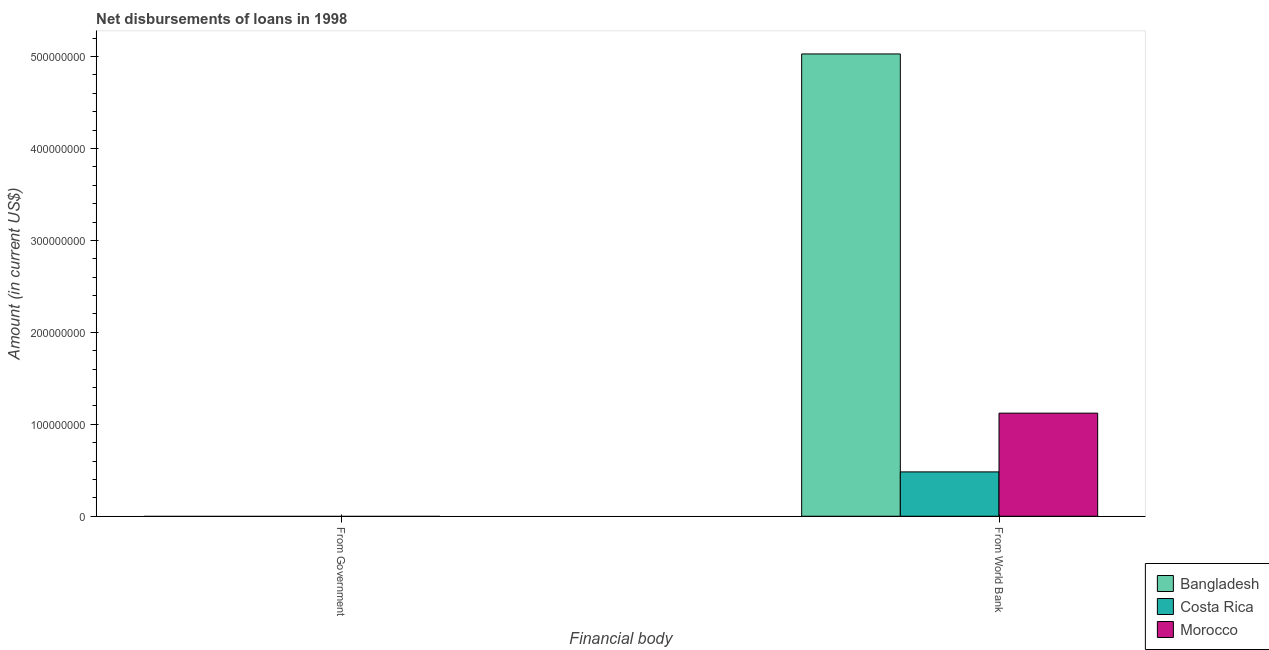Are the number of bars per tick equal to the number of legend labels?
Ensure brevity in your answer.  No. Are the number of bars on each tick of the X-axis equal?
Ensure brevity in your answer.  No. What is the label of the 2nd group of bars from the left?
Make the answer very short. From World Bank. What is the net disbursements of loan from government in Morocco?
Keep it short and to the point. 0. Across all countries, what is the maximum net disbursements of loan from world bank?
Provide a short and direct response. 5.03e+08. Across all countries, what is the minimum net disbursements of loan from world bank?
Your response must be concise. 4.82e+07. In which country was the net disbursements of loan from world bank maximum?
Make the answer very short. Bangladesh. What is the total net disbursements of loan from world bank in the graph?
Offer a terse response. 6.63e+08. What is the difference between the net disbursements of loan from world bank in Costa Rica and that in Morocco?
Keep it short and to the point. -6.39e+07. What is the difference between the net disbursements of loan from world bank in Costa Rica and the net disbursements of loan from government in Morocco?
Offer a terse response. 4.82e+07. What is the ratio of the net disbursements of loan from world bank in Costa Rica to that in Morocco?
Offer a terse response. 0.43. In how many countries, is the net disbursements of loan from government greater than the average net disbursements of loan from government taken over all countries?
Your answer should be very brief. 0. How many bars are there?
Your answer should be compact. 3. Are the values on the major ticks of Y-axis written in scientific E-notation?
Make the answer very short. No. Does the graph contain any zero values?
Offer a terse response. Yes. How many legend labels are there?
Ensure brevity in your answer.  3. What is the title of the graph?
Ensure brevity in your answer.  Net disbursements of loans in 1998. Does "Iceland" appear as one of the legend labels in the graph?
Provide a succinct answer. No. What is the label or title of the X-axis?
Offer a very short reply. Financial body. What is the Amount (in current US$) in Morocco in From Government?
Your response must be concise. 0. What is the Amount (in current US$) of Bangladesh in From World Bank?
Provide a succinct answer. 5.03e+08. What is the Amount (in current US$) of Costa Rica in From World Bank?
Keep it short and to the point. 4.82e+07. What is the Amount (in current US$) of Morocco in From World Bank?
Offer a terse response. 1.12e+08. Across all Financial body, what is the maximum Amount (in current US$) of Bangladesh?
Provide a short and direct response. 5.03e+08. Across all Financial body, what is the maximum Amount (in current US$) of Costa Rica?
Your answer should be very brief. 4.82e+07. Across all Financial body, what is the maximum Amount (in current US$) in Morocco?
Keep it short and to the point. 1.12e+08. Across all Financial body, what is the minimum Amount (in current US$) in Bangladesh?
Keep it short and to the point. 0. Across all Financial body, what is the minimum Amount (in current US$) of Morocco?
Your answer should be very brief. 0. What is the total Amount (in current US$) of Bangladesh in the graph?
Offer a terse response. 5.03e+08. What is the total Amount (in current US$) of Costa Rica in the graph?
Make the answer very short. 4.82e+07. What is the total Amount (in current US$) of Morocco in the graph?
Your answer should be compact. 1.12e+08. What is the average Amount (in current US$) in Bangladesh per Financial body?
Offer a terse response. 2.51e+08. What is the average Amount (in current US$) in Costa Rica per Financial body?
Your response must be concise. 2.41e+07. What is the average Amount (in current US$) of Morocco per Financial body?
Keep it short and to the point. 5.61e+07. What is the difference between the Amount (in current US$) in Bangladesh and Amount (in current US$) in Costa Rica in From World Bank?
Give a very brief answer. 4.55e+08. What is the difference between the Amount (in current US$) of Bangladesh and Amount (in current US$) of Morocco in From World Bank?
Provide a short and direct response. 3.91e+08. What is the difference between the Amount (in current US$) of Costa Rica and Amount (in current US$) of Morocco in From World Bank?
Ensure brevity in your answer.  -6.39e+07. What is the difference between the highest and the lowest Amount (in current US$) in Bangladesh?
Provide a short and direct response. 5.03e+08. What is the difference between the highest and the lowest Amount (in current US$) in Costa Rica?
Make the answer very short. 4.82e+07. What is the difference between the highest and the lowest Amount (in current US$) in Morocco?
Offer a very short reply. 1.12e+08. 